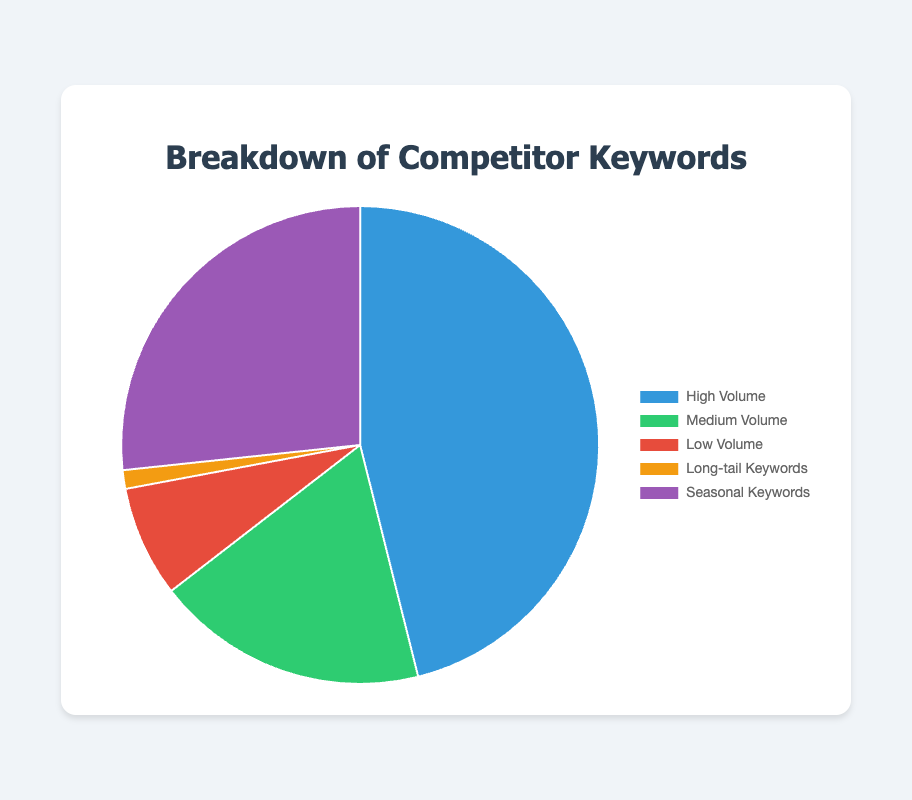Which category has the highest search volume? The pie chart visually represents the total search volumes for different keyword categories. The category with the largest slice represents the highest search volume. Here, High Volume has the largest slice.
Answer: High Volume What is the combined search volume for Low Volume and Long-tail Keywords? Sum the search volumes of the Low Volume and Long-tail Keywords categories. For Low Volume: 8000 + 7500 = 15500. For Long-tail Keywords: 1200 + 1400 = 2600. Combined: 15500 + 2600 = 18100.
Answer: 18100 Which category has more searches, High Volume or Seasonal Keywords? Compare the total search volumes of both categories. High Volume has 50000 (best laptops 2023) + 45000 (cheap flights) = 95000, and Seasonal Keywords has 30000 (christmas gift ideas) + 25000 (best costumes for Halloween) = 55000.
Answer: High Volume What percentage of the total search volume is contributed by Medium Volume keywords? Calculate the total search volume, then determine the percentage contributed by Medium Volume. Total search volume = 95000 (High Volume) + 38000 (Medium Volume) + 15500 (Low Volume) + 2600 (Long-tail Keywords) + 55000 (Seasonal Keywords) = 206100. Medium Volume = 38000. Percentage = (38000 / 206100) * 100 = 18.43%.
Answer: 18.43% Which keyword category is represented by the smallest slice, and what is the combined search volume for that category? The smallest slice in the pie chart visually represents the category with the lowest total search volume. Long-tail Keywords are represented by the smallest slice with combined search volume of 1200 + 1400 = 2600.
Answer: Long-tail Keywords, 2600 How does the search volume of "best costumes for Halloween" compare to "best yoga mats"? Compare the search volumes of the two keywords. "best costumes for Halloween" has a search volume of 25000, and "best yoga mats" has 7500. 25000 is greater than 7500.
Answer: "best costumes for Halloween" has more searches What's the average search volume per category? Calculate the average by summing the total search volumes and dividing by the number of categories. Total search volume is 206100 and there are 5 categories. Average = 206100 / 5 = 41220.
Answer: 41220 If "best laptops 2023" were removed, which category would have the highest total search volume? Removing "best laptops 2023" (50000) from High Volume results in High Volume having 45000 searches left. The next highest category is Seasonal Keywords with 55000.
Answer: Seasonal Keywords How much larger is the search volume for High Volume keywords compared to Long-tail Keywords? Subtract the total search volume of Long-tail Keywords from High Volume. High Volume = 95000, Long-tail Keywords = 2600. Difference = 95000 - 2600 = 92400.
Answer: 92400 Which category represents exactly 18,000 searches? Review the search volumes for each category. The keyword "current mortgage rates" in the Medium Volume category has precisely 18,000 searches.
Answer: Medium Volume 